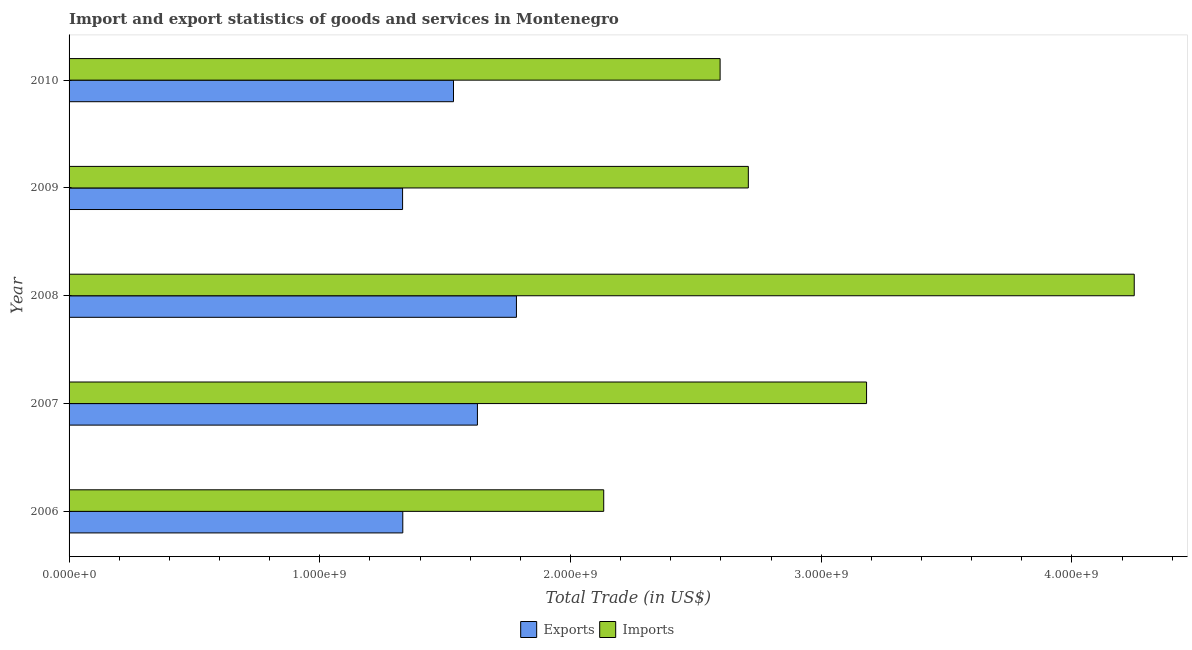How many different coloured bars are there?
Your answer should be compact. 2. Are the number of bars on each tick of the Y-axis equal?
Your response must be concise. Yes. How many bars are there on the 4th tick from the top?
Ensure brevity in your answer.  2. How many bars are there on the 3rd tick from the bottom?
Give a very brief answer. 2. What is the label of the 3rd group of bars from the top?
Your response must be concise. 2008. What is the imports of goods and services in 2007?
Your response must be concise. 3.18e+09. Across all years, what is the maximum imports of goods and services?
Ensure brevity in your answer.  4.25e+09. Across all years, what is the minimum imports of goods and services?
Provide a short and direct response. 2.13e+09. In which year was the imports of goods and services maximum?
Provide a short and direct response. 2008. In which year was the export of goods and services minimum?
Offer a very short reply. 2009. What is the total export of goods and services in the graph?
Offer a terse response. 7.61e+09. What is the difference between the export of goods and services in 2006 and that in 2009?
Provide a short and direct response. 8.57e+05. What is the difference between the export of goods and services in 2006 and the imports of goods and services in 2009?
Your answer should be compact. -1.38e+09. What is the average imports of goods and services per year?
Your answer should be very brief. 2.97e+09. In the year 2010, what is the difference between the export of goods and services and imports of goods and services?
Make the answer very short. -1.06e+09. In how many years, is the imports of goods and services greater than 1800000000 US$?
Make the answer very short. 5. What is the ratio of the imports of goods and services in 2008 to that in 2010?
Your answer should be compact. 1.64. Is the export of goods and services in 2008 less than that in 2009?
Keep it short and to the point. No. What is the difference between the highest and the second highest export of goods and services?
Give a very brief answer. 1.56e+08. What is the difference between the highest and the lowest export of goods and services?
Your response must be concise. 4.54e+08. In how many years, is the export of goods and services greater than the average export of goods and services taken over all years?
Your response must be concise. 3. What does the 2nd bar from the top in 2010 represents?
Make the answer very short. Exports. What does the 2nd bar from the bottom in 2007 represents?
Your answer should be compact. Imports. How many bars are there?
Give a very brief answer. 10. Are all the bars in the graph horizontal?
Give a very brief answer. Yes. What is the difference between two consecutive major ticks on the X-axis?
Your answer should be compact. 1.00e+09. Are the values on the major ticks of X-axis written in scientific E-notation?
Keep it short and to the point. Yes. Does the graph contain grids?
Keep it short and to the point. No. How many legend labels are there?
Provide a short and direct response. 2. What is the title of the graph?
Ensure brevity in your answer.  Import and export statistics of goods and services in Montenegro. Does "Personal remittances" appear as one of the legend labels in the graph?
Keep it short and to the point. No. What is the label or title of the X-axis?
Your answer should be compact. Total Trade (in US$). What is the Total Trade (in US$) in Exports in 2006?
Your answer should be very brief. 1.33e+09. What is the Total Trade (in US$) of Imports in 2006?
Your response must be concise. 2.13e+09. What is the Total Trade (in US$) in Exports in 2007?
Your response must be concise. 1.63e+09. What is the Total Trade (in US$) in Imports in 2007?
Keep it short and to the point. 3.18e+09. What is the Total Trade (in US$) in Exports in 2008?
Your response must be concise. 1.78e+09. What is the Total Trade (in US$) of Imports in 2008?
Offer a terse response. 4.25e+09. What is the Total Trade (in US$) of Exports in 2009?
Give a very brief answer. 1.33e+09. What is the Total Trade (in US$) of Imports in 2009?
Offer a very short reply. 2.71e+09. What is the Total Trade (in US$) in Exports in 2010?
Offer a very short reply. 1.53e+09. What is the Total Trade (in US$) in Imports in 2010?
Make the answer very short. 2.60e+09. Across all years, what is the maximum Total Trade (in US$) in Exports?
Your answer should be compact. 1.78e+09. Across all years, what is the maximum Total Trade (in US$) in Imports?
Make the answer very short. 4.25e+09. Across all years, what is the minimum Total Trade (in US$) of Exports?
Provide a short and direct response. 1.33e+09. Across all years, what is the minimum Total Trade (in US$) in Imports?
Offer a very short reply. 2.13e+09. What is the total Total Trade (in US$) of Exports in the graph?
Make the answer very short. 7.61e+09. What is the total Total Trade (in US$) of Imports in the graph?
Offer a very short reply. 1.49e+1. What is the difference between the Total Trade (in US$) in Exports in 2006 and that in 2007?
Your answer should be compact. -2.98e+08. What is the difference between the Total Trade (in US$) of Imports in 2006 and that in 2007?
Make the answer very short. -1.05e+09. What is the difference between the Total Trade (in US$) of Exports in 2006 and that in 2008?
Offer a terse response. -4.53e+08. What is the difference between the Total Trade (in US$) of Imports in 2006 and that in 2008?
Your response must be concise. -2.12e+09. What is the difference between the Total Trade (in US$) of Exports in 2006 and that in 2009?
Give a very brief answer. 8.57e+05. What is the difference between the Total Trade (in US$) of Imports in 2006 and that in 2009?
Give a very brief answer. -5.77e+08. What is the difference between the Total Trade (in US$) in Exports in 2006 and that in 2010?
Your response must be concise. -2.02e+08. What is the difference between the Total Trade (in US$) in Imports in 2006 and that in 2010?
Keep it short and to the point. -4.64e+08. What is the difference between the Total Trade (in US$) in Exports in 2007 and that in 2008?
Provide a short and direct response. -1.56e+08. What is the difference between the Total Trade (in US$) in Imports in 2007 and that in 2008?
Your answer should be compact. -1.07e+09. What is the difference between the Total Trade (in US$) of Exports in 2007 and that in 2009?
Keep it short and to the point. 2.99e+08. What is the difference between the Total Trade (in US$) of Imports in 2007 and that in 2009?
Provide a succinct answer. 4.72e+08. What is the difference between the Total Trade (in US$) in Exports in 2007 and that in 2010?
Offer a very short reply. 9.54e+07. What is the difference between the Total Trade (in US$) of Imports in 2007 and that in 2010?
Give a very brief answer. 5.84e+08. What is the difference between the Total Trade (in US$) of Exports in 2008 and that in 2009?
Offer a terse response. 4.54e+08. What is the difference between the Total Trade (in US$) of Imports in 2008 and that in 2009?
Provide a succinct answer. 1.54e+09. What is the difference between the Total Trade (in US$) in Exports in 2008 and that in 2010?
Keep it short and to the point. 2.51e+08. What is the difference between the Total Trade (in US$) of Imports in 2008 and that in 2010?
Ensure brevity in your answer.  1.65e+09. What is the difference between the Total Trade (in US$) of Exports in 2009 and that in 2010?
Keep it short and to the point. -2.03e+08. What is the difference between the Total Trade (in US$) in Imports in 2009 and that in 2010?
Your answer should be very brief. 1.13e+08. What is the difference between the Total Trade (in US$) of Exports in 2006 and the Total Trade (in US$) of Imports in 2007?
Make the answer very short. -1.85e+09. What is the difference between the Total Trade (in US$) in Exports in 2006 and the Total Trade (in US$) in Imports in 2008?
Provide a short and direct response. -2.92e+09. What is the difference between the Total Trade (in US$) of Exports in 2006 and the Total Trade (in US$) of Imports in 2009?
Provide a succinct answer. -1.38e+09. What is the difference between the Total Trade (in US$) in Exports in 2006 and the Total Trade (in US$) in Imports in 2010?
Your answer should be very brief. -1.27e+09. What is the difference between the Total Trade (in US$) of Exports in 2007 and the Total Trade (in US$) of Imports in 2008?
Ensure brevity in your answer.  -2.62e+09. What is the difference between the Total Trade (in US$) in Exports in 2007 and the Total Trade (in US$) in Imports in 2009?
Your response must be concise. -1.08e+09. What is the difference between the Total Trade (in US$) of Exports in 2007 and the Total Trade (in US$) of Imports in 2010?
Give a very brief answer. -9.68e+08. What is the difference between the Total Trade (in US$) in Exports in 2008 and the Total Trade (in US$) in Imports in 2009?
Offer a terse response. -9.25e+08. What is the difference between the Total Trade (in US$) of Exports in 2008 and the Total Trade (in US$) of Imports in 2010?
Offer a terse response. -8.12e+08. What is the difference between the Total Trade (in US$) in Exports in 2009 and the Total Trade (in US$) in Imports in 2010?
Provide a short and direct response. -1.27e+09. What is the average Total Trade (in US$) of Exports per year?
Keep it short and to the point. 1.52e+09. What is the average Total Trade (in US$) of Imports per year?
Make the answer very short. 2.97e+09. In the year 2006, what is the difference between the Total Trade (in US$) in Exports and Total Trade (in US$) in Imports?
Make the answer very short. -8.01e+08. In the year 2007, what is the difference between the Total Trade (in US$) in Exports and Total Trade (in US$) in Imports?
Ensure brevity in your answer.  -1.55e+09. In the year 2008, what is the difference between the Total Trade (in US$) of Exports and Total Trade (in US$) of Imports?
Offer a very short reply. -2.46e+09. In the year 2009, what is the difference between the Total Trade (in US$) of Exports and Total Trade (in US$) of Imports?
Your answer should be very brief. -1.38e+09. In the year 2010, what is the difference between the Total Trade (in US$) in Exports and Total Trade (in US$) in Imports?
Provide a succinct answer. -1.06e+09. What is the ratio of the Total Trade (in US$) in Exports in 2006 to that in 2007?
Your answer should be very brief. 0.82. What is the ratio of the Total Trade (in US$) of Imports in 2006 to that in 2007?
Ensure brevity in your answer.  0.67. What is the ratio of the Total Trade (in US$) of Exports in 2006 to that in 2008?
Give a very brief answer. 0.75. What is the ratio of the Total Trade (in US$) of Imports in 2006 to that in 2008?
Your answer should be very brief. 0.5. What is the ratio of the Total Trade (in US$) of Exports in 2006 to that in 2009?
Offer a terse response. 1. What is the ratio of the Total Trade (in US$) in Imports in 2006 to that in 2009?
Provide a short and direct response. 0.79. What is the ratio of the Total Trade (in US$) in Exports in 2006 to that in 2010?
Provide a short and direct response. 0.87. What is the ratio of the Total Trade (in US$) of Imports in 2006 to that in 2010?
Make the answer very short. 0.82. What is the ratio of the Total Trade (in US$) of Exports in 2007 to that in 2008?
Keep it short and to the point. 0.91. What is the ratio of the Total Trade (in US$) in Imports in 2007 to that in 2008?
Keep it short and to the point. 0.75. What is the ratio of the Total Trade (in US$) of Exports in 2007 to that in 2009?
Make the answer very short. 1.22. What is the ratio of the Total Trade (in US$) of Imports in 2007 to that in 2009?
Keep it short and to the point. 1.17. What is the ratio of the Total Trade (in US$) in Exports in 2007 to that in 2010?
Make the answer very short. 1.06. What is the ratio of the Total Trade (in US$) in Imports in 2007 to that in 2010?
Offer a very short reply. 1.22. What is the ratio of the Total Trade (in US$) in Exports in 2008 to that in 2009?
Keep it short and to the point. 1.34. What is the ratio of the Total Trade (in US$) in Imports in 2008 to that in 2009?
Provide a short and direct response. 1.57. What is the ratio of the Total Trade (in US$) in Exports in 2008 to that in 2010?
Give a very brief answer. 1.16. What is the ratio of the Total Trade (in US$) in Imports in 2008 to that in 2010?
Your response must be concise. 1.64. What is the ratio of the Total Trade (in US$) in Exports in 2009 to that in 2010?
Keep it short and to the point. 0.87. What is the ratio of the Total Trade (in US$) in Imports in 2009 to that in 2010?
Provide a short and direct response. 1.04. What is the difference between the highest and the second highest Total Trade (in US$) in Exports?
Keep it short and to the point. 1.56e+08. What is the difference between the highest and the second highest Total Trade (in US$) of Imports?
Keep it short and to the point. 1.07e+09. What is the difference between the highest and the lowest Total Trade (in US$) in Exports?
Make the answer very short. 4.54e+08. What is the difference between the highest and the lowest Total Trade (in US$) of Imports?
Your answer should be compact. 2.12e+09. 